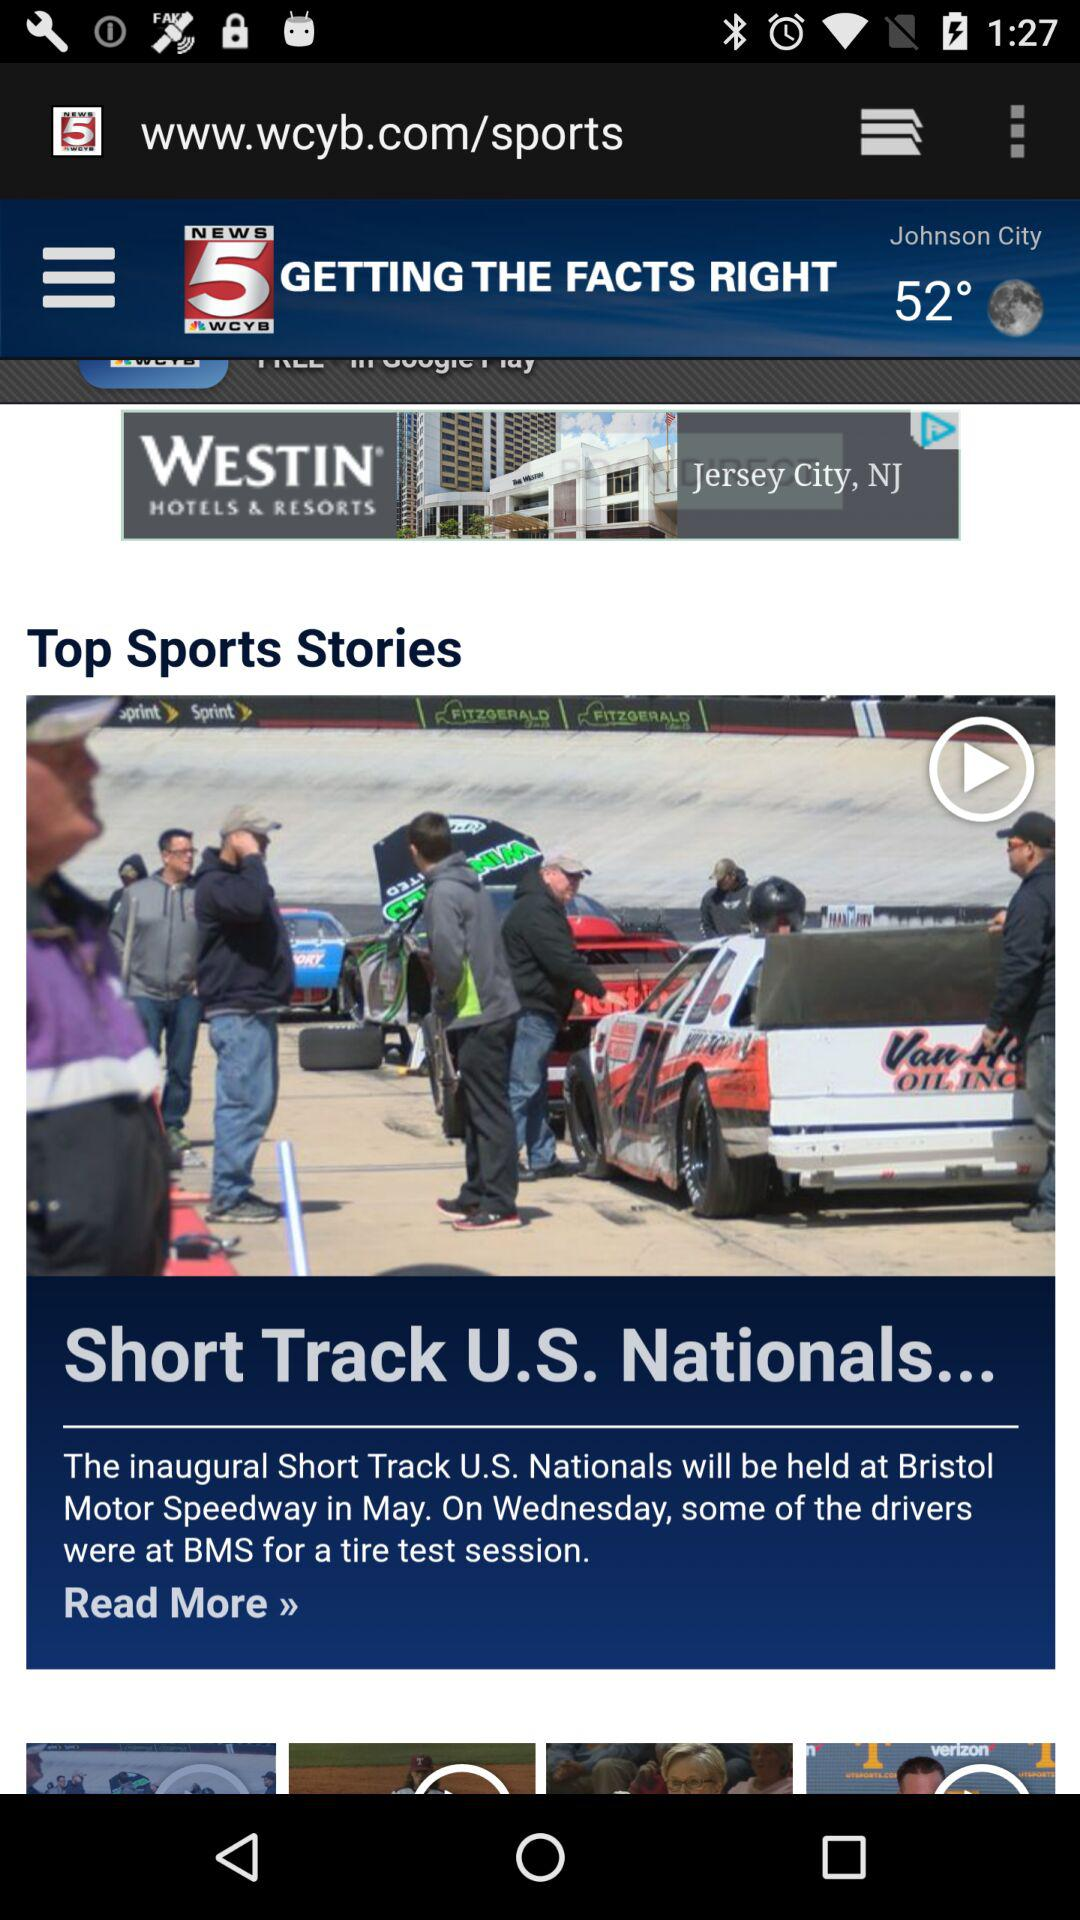Where will the inaugural Short Track U.S. Nationals be held? The inaugural Short Track U.S. Nationals will be held at Bristol. 